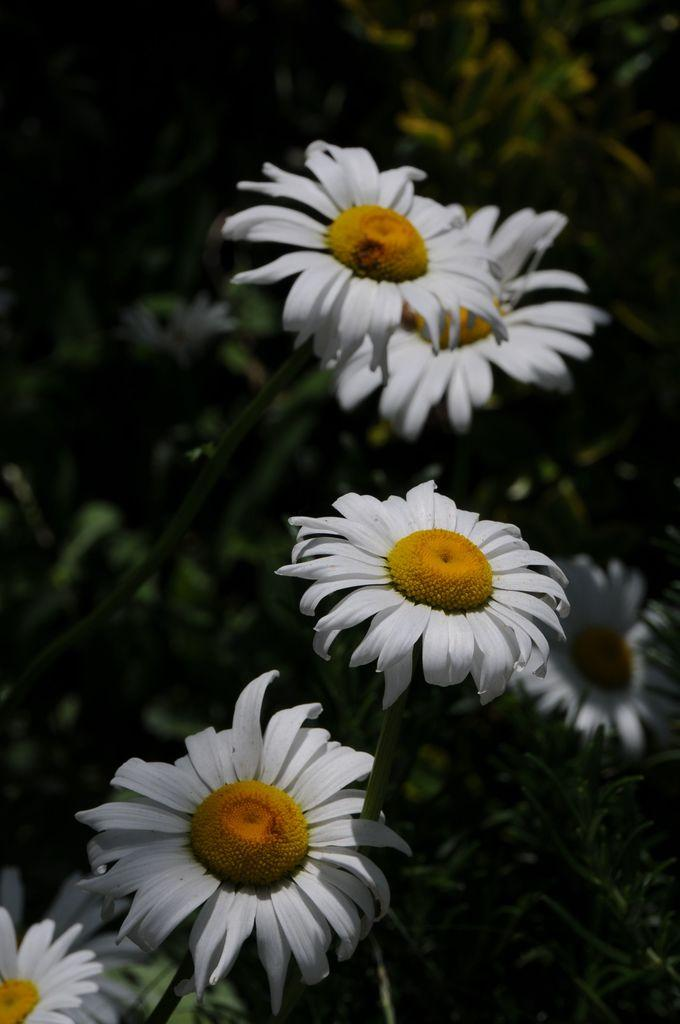What is located in the center of the image? There are plants in the center of the image. What type of plants are present in the image? There are flowers in the image. What colors can be seen on the flowers? The flowers are white and yellow in color. What type of nail is being used by the writer in the image? There is no writer or nail present in the image; it features plants and flowers. 